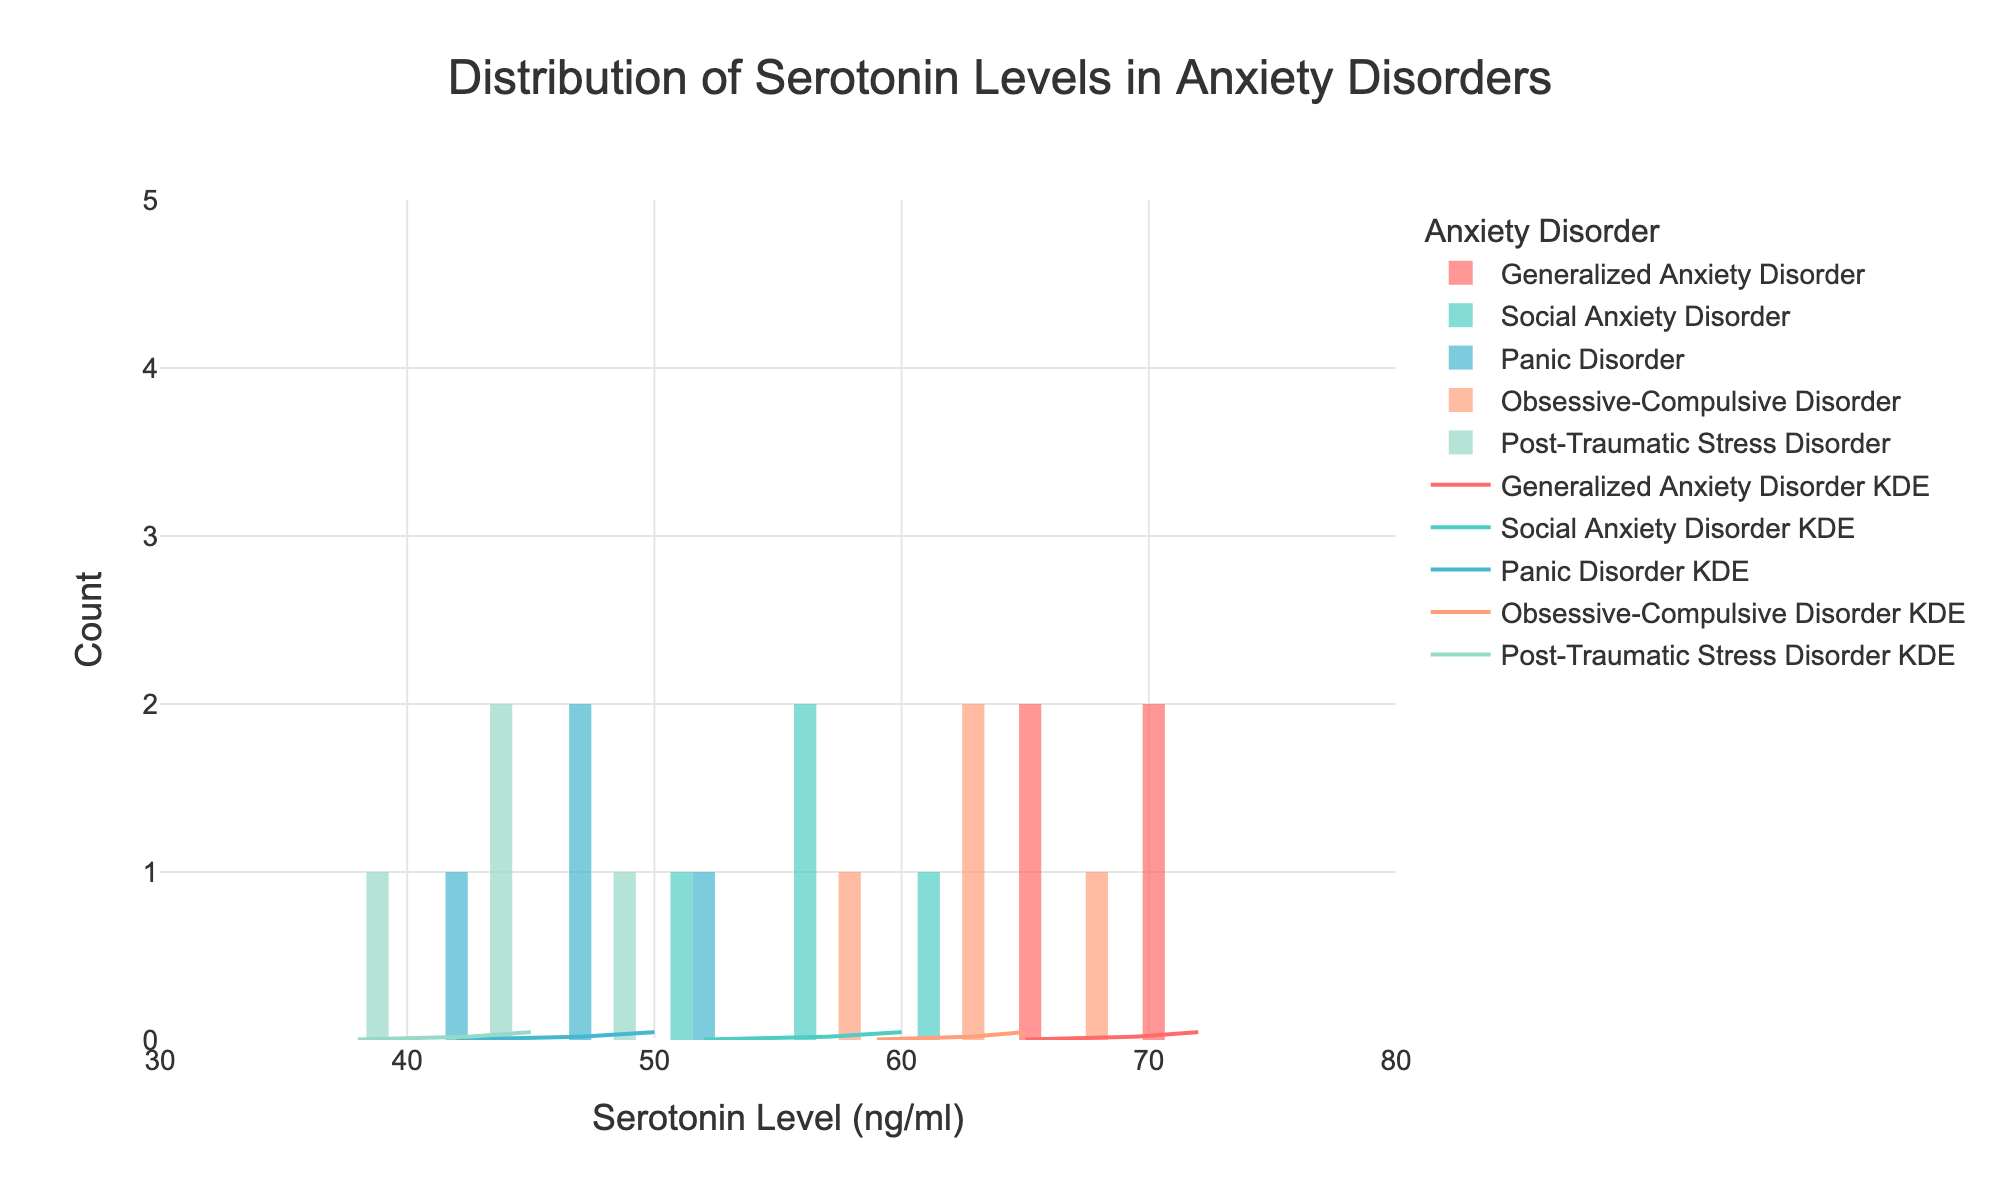What is the title of the figure? The title is located at the top center of the figure. It is clearly indicated and describes what the figure is about.
Answer: Distribution of Serotonin Levels in Anxiety Disorders Which anxiety disorder has the highest average serotonin level? By visually inspecting the KDE curves and the positions of the histogram bins, Generalized Anxiety Disorder appears to have the highest average serotonin levels since its histogram is centered around the highest serotonin levels.
Answer: Generalized Anxiety Disorder What is the range of serotonin levels for Panic Disorder? The x-axis shows the serotonin levels, and by looking at the bins for Panic Disorder, the range can be determined.
Answer: 42 to 50 ng/ml Compare the spread of serotonin levels between Social Anxiety Disorder and Post-Traumatic Stress Disorder. The spread is judged by the width of the histograms and KDE curves. Social Anxiety Disorder has a wider spread of serotonin levels than Post-Traumatic Stress Disorder.
Answer: Social Anxiety Disorder has a wider spread How does the peak of the KDE curve for Generalized Anxiety Disorder compare with that of Obsessive-Compulsive Disorder? The height of the KDE curve peak indicates the density. The KDE curve for Generalized Anxiety Disorder has a higher peak than Obsessive-Compulsive Disorder.
Answer: Higher peak for Generalized Anxiety Disorder Which disorder has the lowest serotonin level and what is it? Looking at the histograms, the lowest serotonin level occurs in Post-Traumatic Stress Disorder.
Answer: Post-Traumatic Stress Disorder, 38 ng/ml How many serotonin level bins are used in the histograms? The number of bins in the histograms can be counted along the x-axis. The figure uses 10 bins.
Answer: 10 bins What can be inferred about serotonin levels in Post-Traumatic Stress Disorder based on its KDE curve? The KDE curve for Post-Traumatic Stress Disorder is lower and narrower compared to others, suggesting lower and less variable serotonin levels in these patients.
Answer: Lower and less variable serotonin levels Which disorder's KDE curve overlaps the most with Social Anxiety Disorder? By comparing the KDE curves, Generalized Anxiety Disorder’s KDE curve overlaps the most with that of Social Anxiety Disorder.
Answer: Generalized Anxiety Disorder Is there any disorder with a non-overlapping KDE curve? Examining the KDE curves, Panic Disorder has a fairly distinct KDE curve that does not significantly overlap with others.
Answer: Panic Disorder 